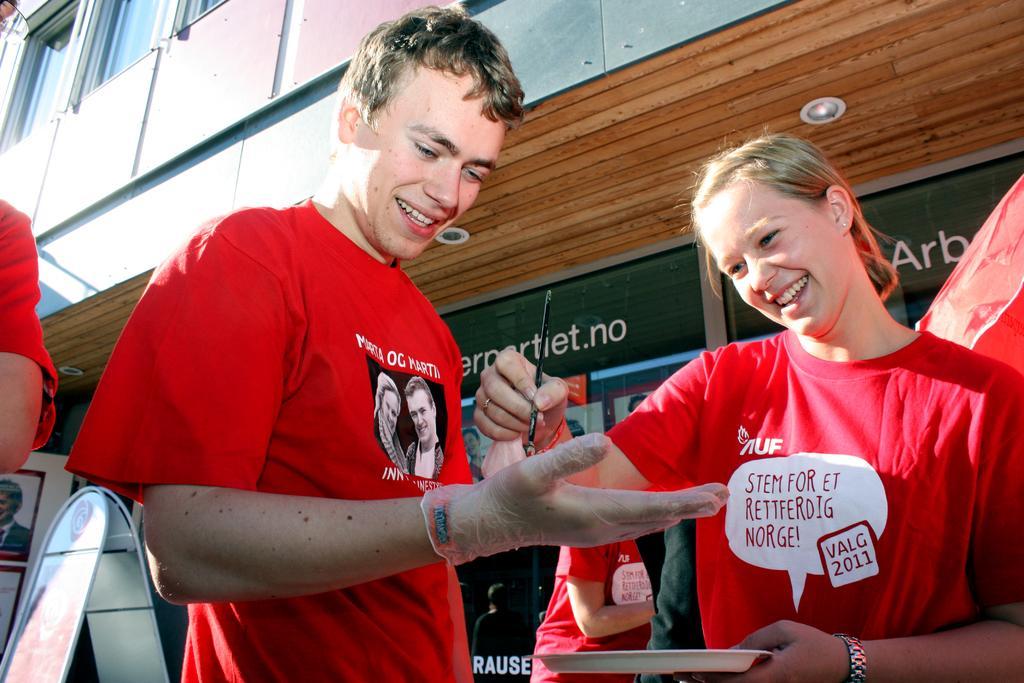Can you describe this image briefly? In this picture I can see group of people standing, there is a person holding a paint brush and a plate, and in the background there are boards and a building. 